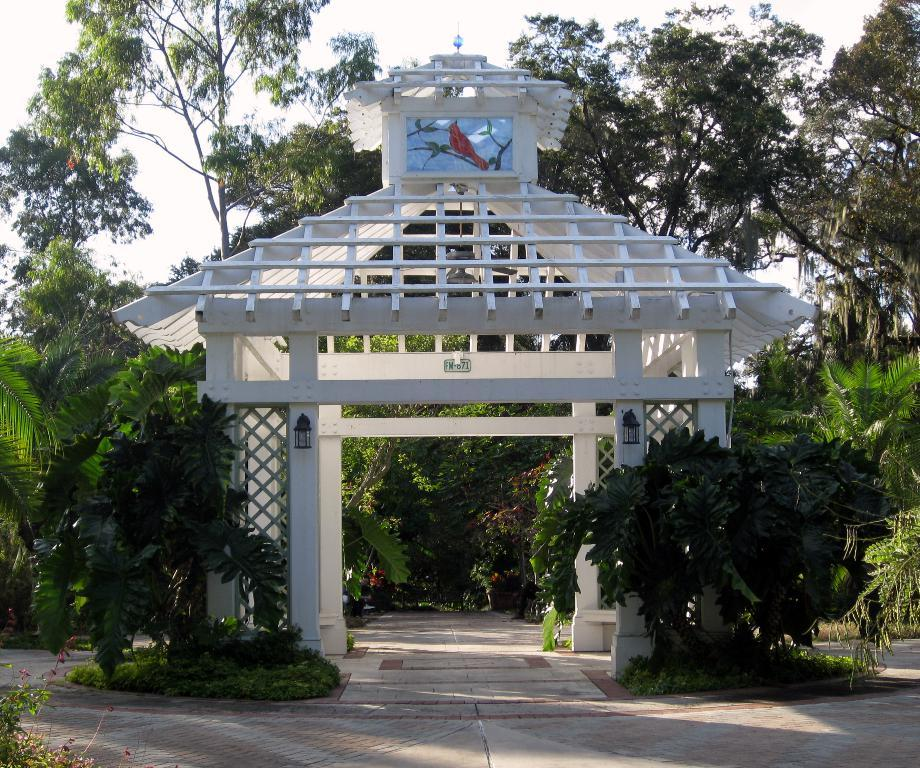What type of structure is in the foreground of the image? There is a shelter-like architecture in the foreground of the image. What can be seen around the shelter? Trees are present around the shelter. What is at the bottom of the image? There is pavement at the bottom of the image. What is visible at the top of the image? The sky is visible at the top of the image. What type of prose is being recited by the trees in the image? There is no indication in the image that the trees are reciting any prose. 